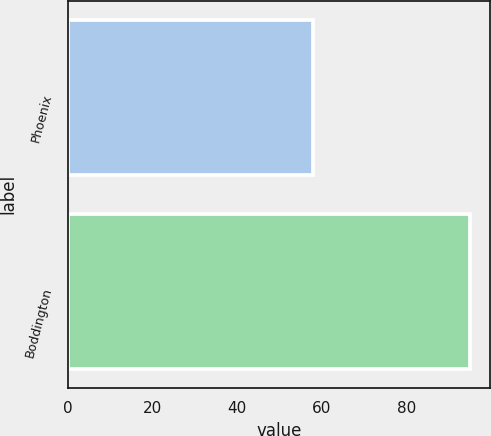Convert chart. <chart><loc_0><loc_0><loc_500><loc_500><bar_chart><fcel>Phoenix<fcel>Boddington<nl><fcel>58<fcel>95<nl></chart> 